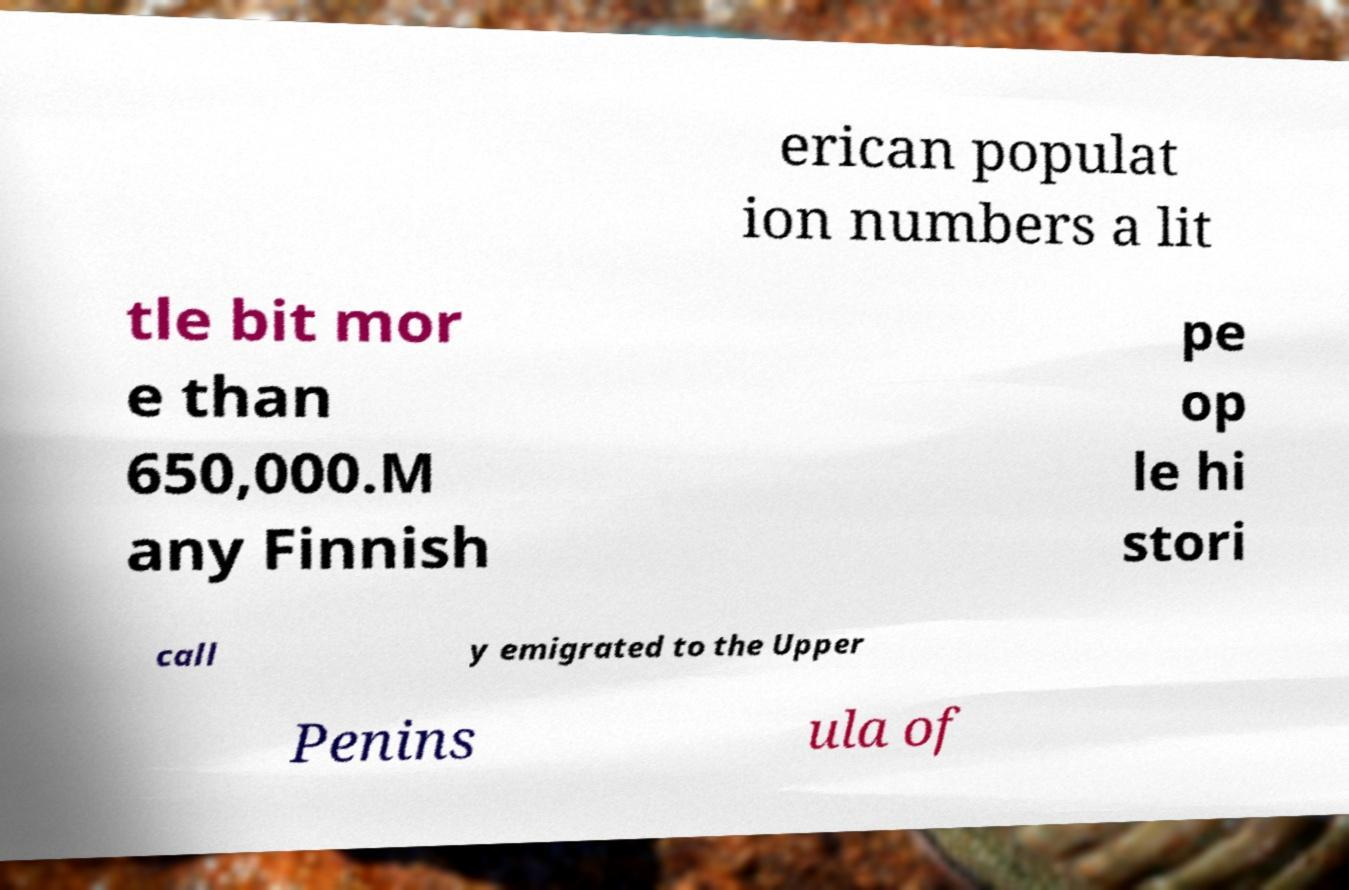What messages or text are displayed in this image? I need them in a readable, typed format. erican populat ion numbers a lit tle bit mor e than 650,000.M any Finnish pe op le hi stori call y emigrated to the Upper Penins ula of 